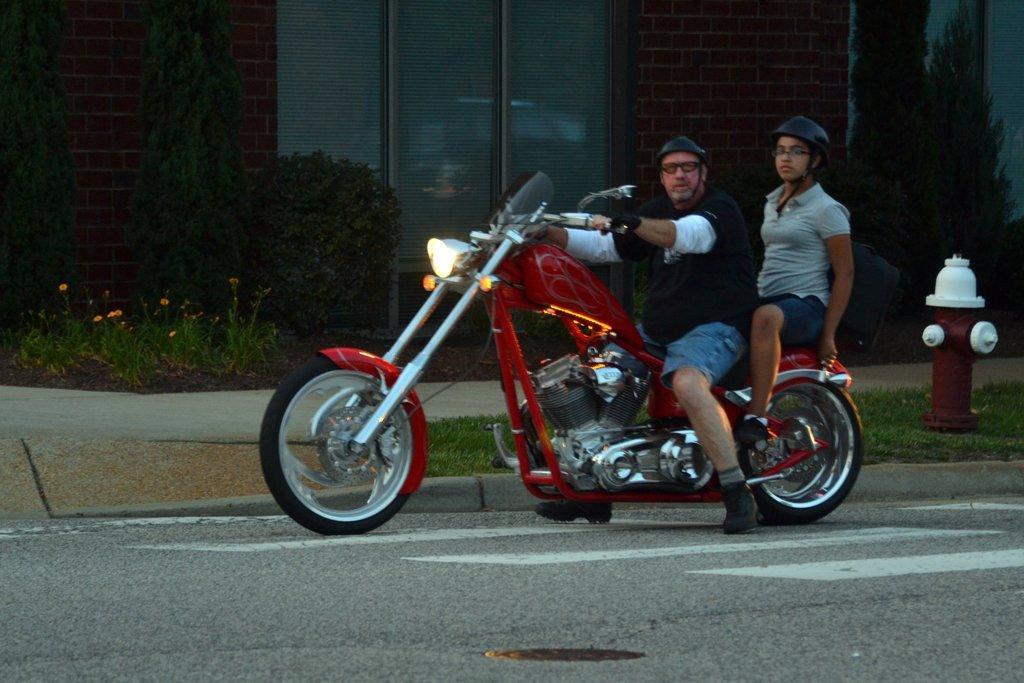How would you summarize this image in a sentence or two? In this image, we can see 2 peoples are riding a motorbike on the road. They wear shorts, t shirts, glasses and helmets. Here right side, we can see pole, grass. The background, we can see glass window and brick wall. Some plants here and here. Here we can see flowers. 